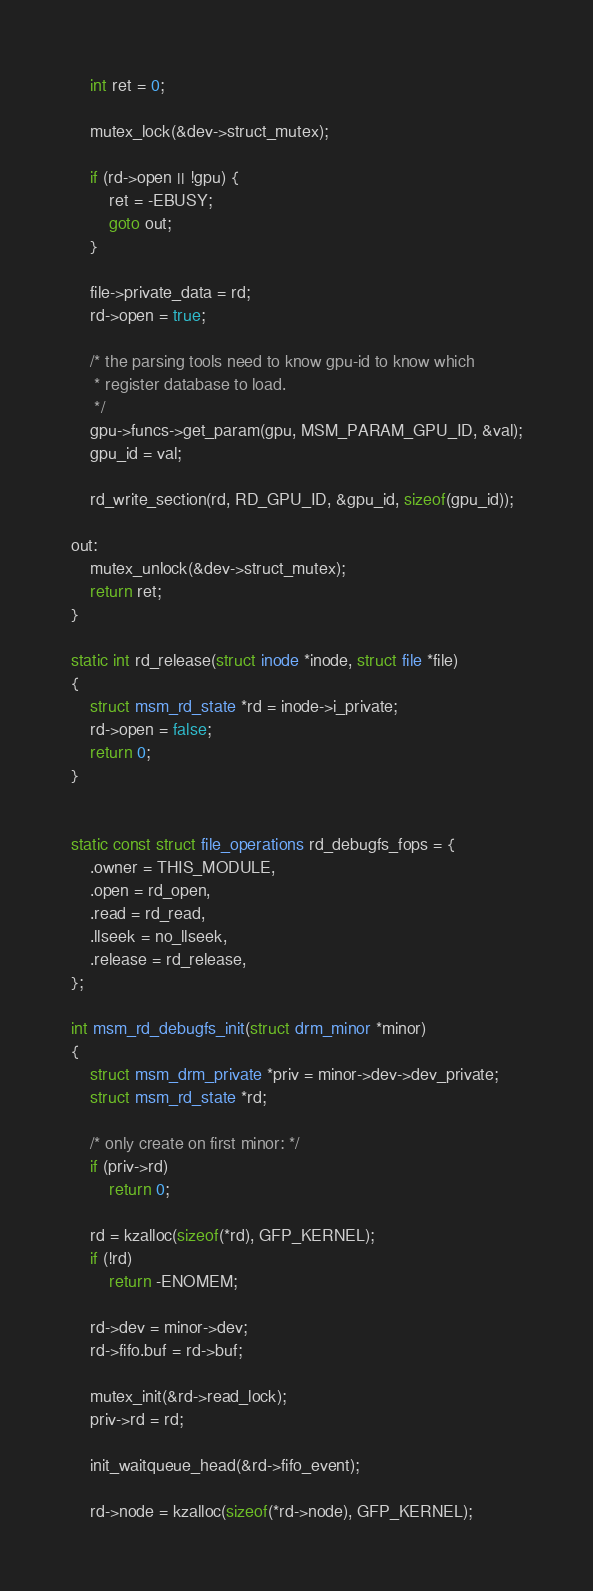<code> <loc_0><loc_0><loc_500><loc_500><_C_>	int ret = 0;

	mutex_lock(&dev->struct_mutex);

	if (rd->open || !gpu) {
		ret = -EBUSY;
		goto out;
	}

	file->private_data = rd;
	rd->open = true;

	/* the parsing tools need to know gpu-id to know which
	 * register database to load.
	 */
	gpu->funcs->get_param(gpu, MSM_PARAM_GPU_ID, &val);
	gpu_id = val;

	rd_write_section(rd, RD_GPU_ID, &gpu_id, sizeof(gpu_id));

out:
	mutex_unlock(&dev->struct_mutex);
	return ret;
}

static int rd_release(struct inode *inode, struct file *file)
{
	struct msm_rd_state *rd = inode->i_private;
	rd->open = false;
	return 0;
}


static const struct file_operations rd_debugfs_fops = {
	.owner = THIS_MODULE,
	.open = rd_open,
	.read = rd_read,
	.llseek = no_llseek,
	.release = rd_release,
};

int msm_rd_debugfs_init(struct drm_minor *minor)
{
	struct msm_drm_private *priv = minor->dev->dev_private;
	struct msm_rd_state *rd;

	/* only create on first minor: */
	if (priv->rd)
		return 0;

	rd = kzalloc(sizeof(*rd), GFP_KERNEL);
	if (!rd)
		return -ENOMEM;

	rd->dev = minor->dev;
	rd->fifo.buf = rd->buf;

	mutex_init(&rd->read_lock);
	priv->rd = rd;

	init_waitqueue_head(&rd->fifo_event);

	rd->node = kzalloc(sizeof(*rd->node), GFP_KERNEL);</code> 